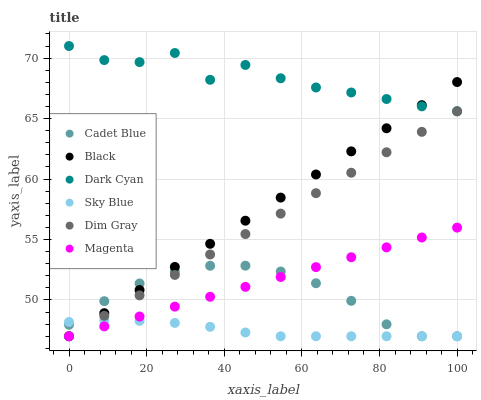Does Sky Blue have the minimum area under the curve?
Answer yes or no. Yes. Does Dark Cyan have the maximum area under the curve?
Answer yes or no. Yes. Does Cadet Blue have the minimum area under the curve?
Answer yes or no. No. Does Cadet Blue have the maximum area under the curve?
Answer yes or no. No. Is Dim Gray the smoothest?
Answer yes or no. Yes. Is Dark Cyan the roughest?
Answer yes or no. Yes. Is Cadet Blue the smoothest?
Answer yes or no. No. Is Cadet Blue the roughest?
Answer yes or no. No. Does Dim Gray have the lowest value?
Answer yes or no. Yes. Does Dark Cyan have the lowest value?
Answer yes or no. No. Does Dark Cyan have the highest value?
Answer yes or no. Yes. Does Cadet Blue have the highest value?
Answer yes or no. No. Is Magenta less than Dark Cyan?
Answer yes or no. Yes. Is Dark Cyan greater than Cadet Blue?
Answer yes or no. Yes. Does Cadet Blue intersect Dim Gray?
Answer yes or no. Yes. Is Cadet Blue less than Dim Gray?
Answer yes or no. No. Is Cadet Blue greater than Dim Gray?
Answer yes or no. No. Does Magenta intersect Dark Cyan?
Answer yes or no. No. 